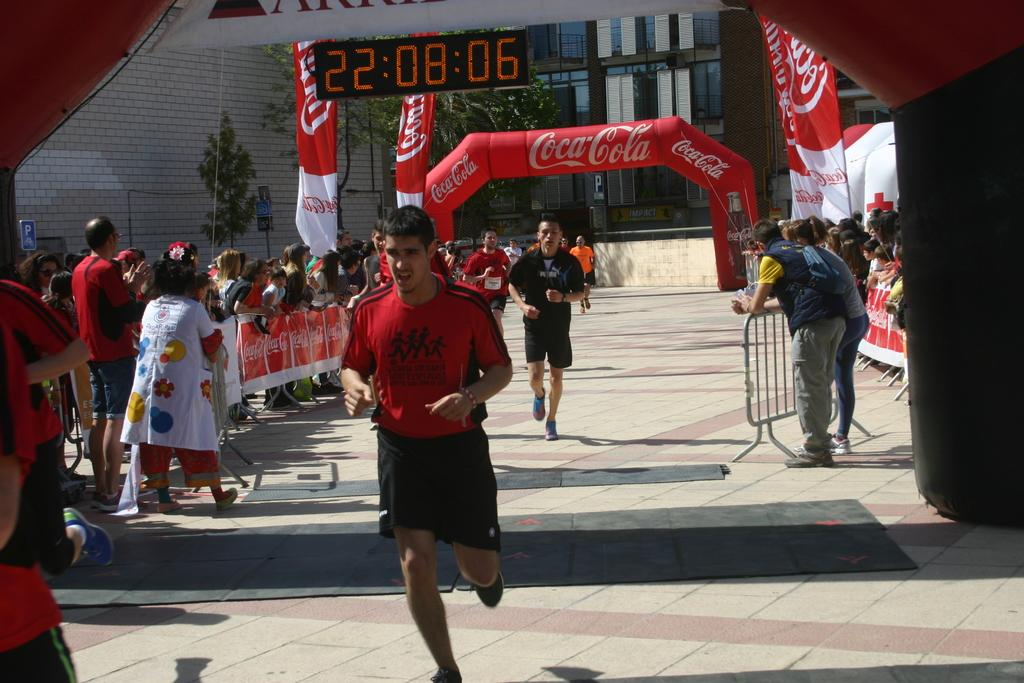How many people are in the group visible in the image? There is a group of people in the image, but the exact number is not specified. What can be seen hanging or displayed in the image? There are banners, a screen, and hoardings visible in the image. What type of barrier is present in the image? There is a fence in the image. What type of vegetation is present in the image? There are trees in the image. What are some of the people in the image doing? There are persons running on the floor in the image. What can be seen in the background of the image? There is a building in the background of the image. What type of coach can be seen in the image? There is no coach present in the image. What is the shape of the heart visible in the image? There is no heart present in the image. 